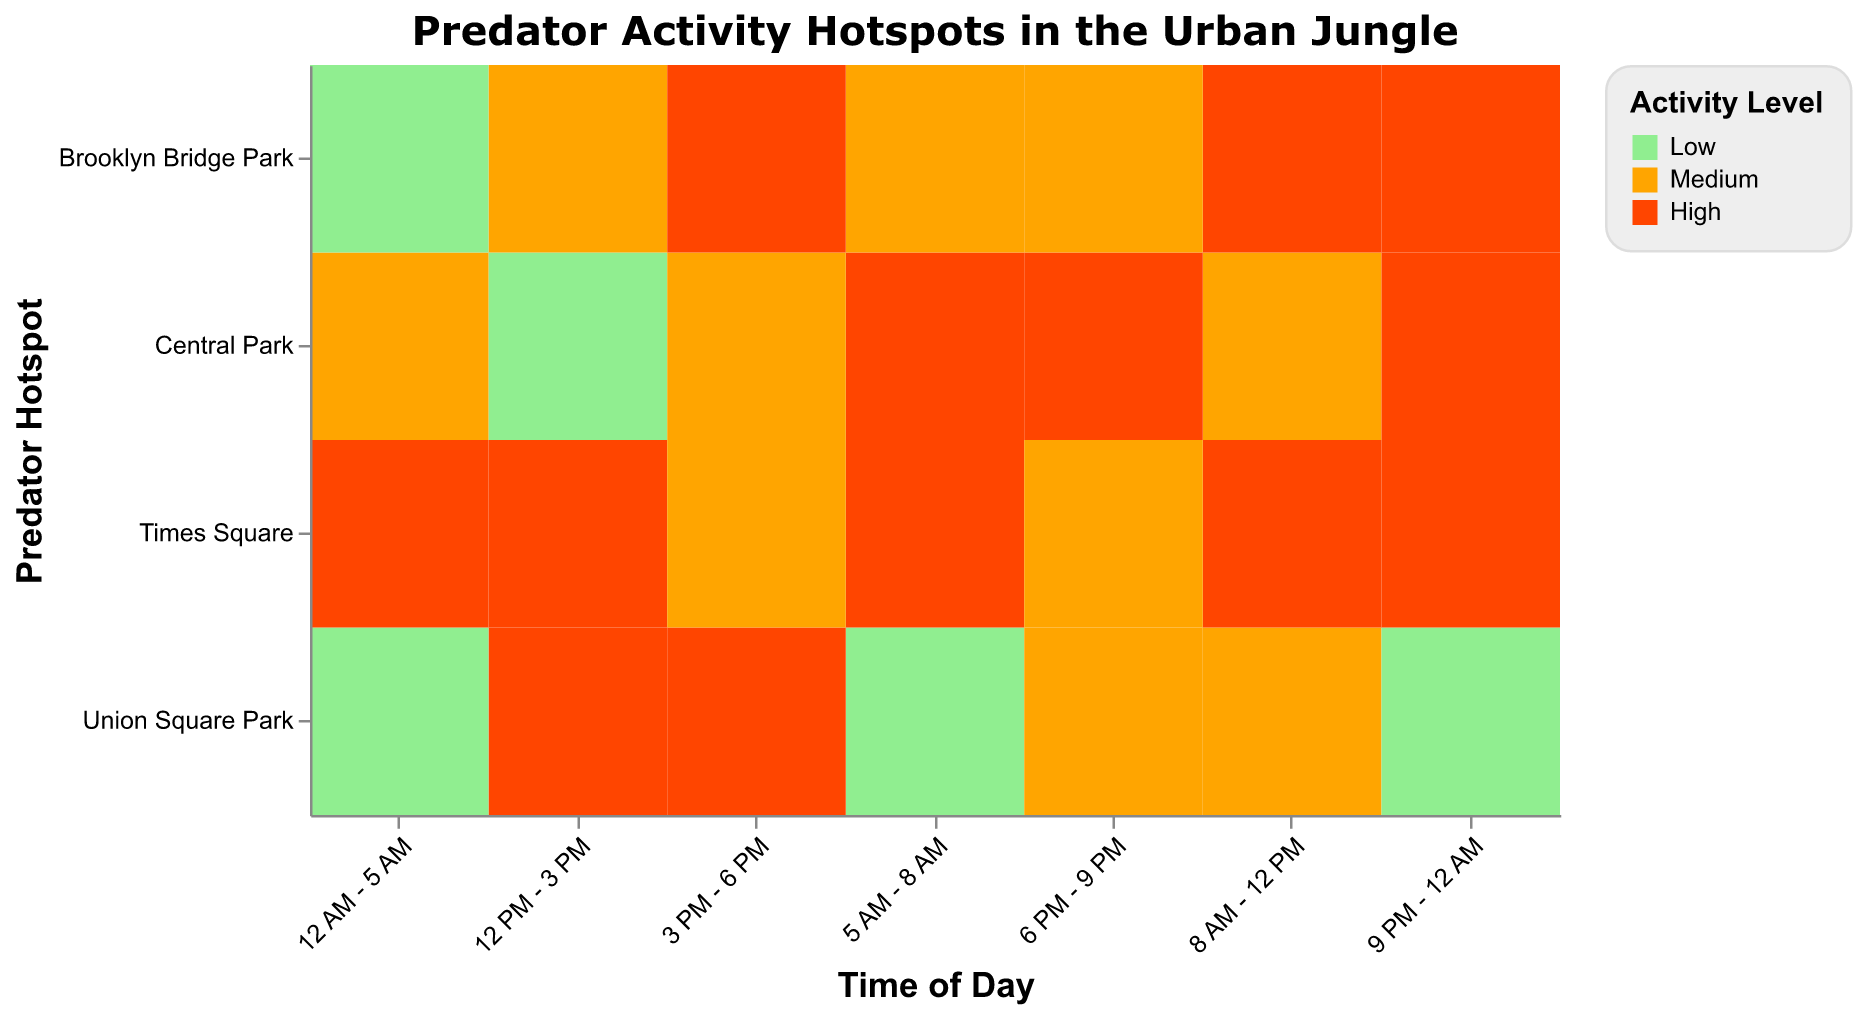What is the highest predator activity level in Central Park? Look for the 'High' activity levels in the Central Park rows. The highest activity levels in Central Park are 'High'.
Answer: High How many time slots in Union Square Park show a low level of predator activity? Count the occurrences of 'Low' in Union Square Park rows. There are three time slots showing a 'Low' level of predator activity.
Answer: 3 Which time of day in Central Park shows the lowest level of predator activity? Identify the 'Low' activity level in the Central Park rows. The lowest activity level occurs in the "12 PM - 3 PM" time slot.
Answer: 12 PM - 3 PM Between Brooklyn Bridge Park and Union Square Park, which one has more 'High' activity levels in the afternoon (12 PM - 3 PM)? Compare the activity levels for the "12 PM - 3 PM" time slot for Brooklyn Bridge Park and Union Square Park. Brooklyn Bridge Park has a 'Medium' activity level, while Union Square Park has a 'High' activity level.
Answer: Union Square Park During which time slots does Times Square show 'Medium' activity levels? Locate the 'Medium' activity levels in Times Square rows. The 'Medium' activity levels occur during the "3 PM - 6 PM" and "6 PM - 9 PM" time slots.
Answer: 3 PM - 6 PM and 6 PM - 9 PM Compare the early morning predator activity level in Central Park and Union Square Park. Which one shows a higher activity level? Identify the '5 AM - 8 AM' time slot in both Central Park and Union Square Park rows. Central Park has a 'High' level, whereas Union Square Park has a 'Low' level. Central Park's activity level is higher.
Answer: Central Park Which park has a 'Low' activity level during the night (9 PM - 12 AM)? Check the '9 PM - 12 AM' time slots for 'Low' activity levels. Only Union Square Park has a 'Low' activity level during that time.
Answer: Union Square Park What is the average level of predator activity in Times Square across all time slots? Assign numerical values to activity levels (Low=1, Medium=2, High=3). Times Square has 7 time slots with activity levels: High (3), High (3), High (3), Medium (2), Medium (2), High (3), High (3). Sum: 3+3+3+2+2+3+3 = 19. Average: 19 / 7 ≈ 2.71. Times Square has an average activity level of approximately 'High'.
Answer: High 